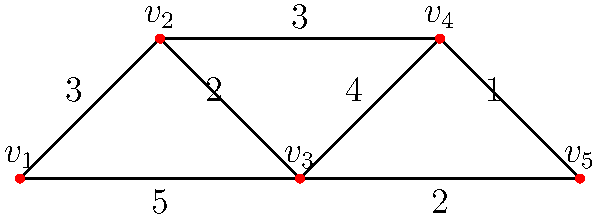In the given graph representation of a player social network in a multiplayer game, vertices represent players and edge weights represent the strength of social connections. What is the minimum number of edges that need to be removed to disconnect players $v_1$ and $v_5$, and what is the total weight of these edges? To solve this problem, we need to find the minimum cut between vertices $v_1$ and $v_5$. Let's approach this step-by-step:

1. Identify all possible paths from $v_1$ to $v_5$:
   Path 1: $v_1 - v_2 - v_3 - v_4 - v_5$
   Path 2: $v_1 - v_2 - v_5$
   Path 3: $v_1 - v_3 - v_4 - v_5$

2. To disconnect $v_1$ and $v_5$, we need to remove at least one edge from each path.

3. Let's consider the minimum number of edges to remove:
   - Removing edge $v_2 - v_5$ (weight 2) disconnects Path 2
   - Removing edge $v_3 - v_4$ (weight 4) disconnects both Path 1 and Path 3

4. These two edges ($v_2 - v_5$ and $v_3 - v_4$) form the minimum cut, as removing them disconnects all paths between $v_1$ and $v_5$.

5. The number of edges in the minimum cut is 2.

6. The total weight of the edges in the minimum cut is:
   Weight of $v_2 - v_5$ + Weight of $v_3 - v_4$ = 2 + 4 = 6

Therefore, the minimum number of edges to be removed is 2, and the total weight of these edges is 6.
Answer: 2 edges; total weight 6 